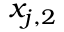<formula> <loc_0><loc_0><loc_500><loc_500>x _ { j , 2 }</formula> 